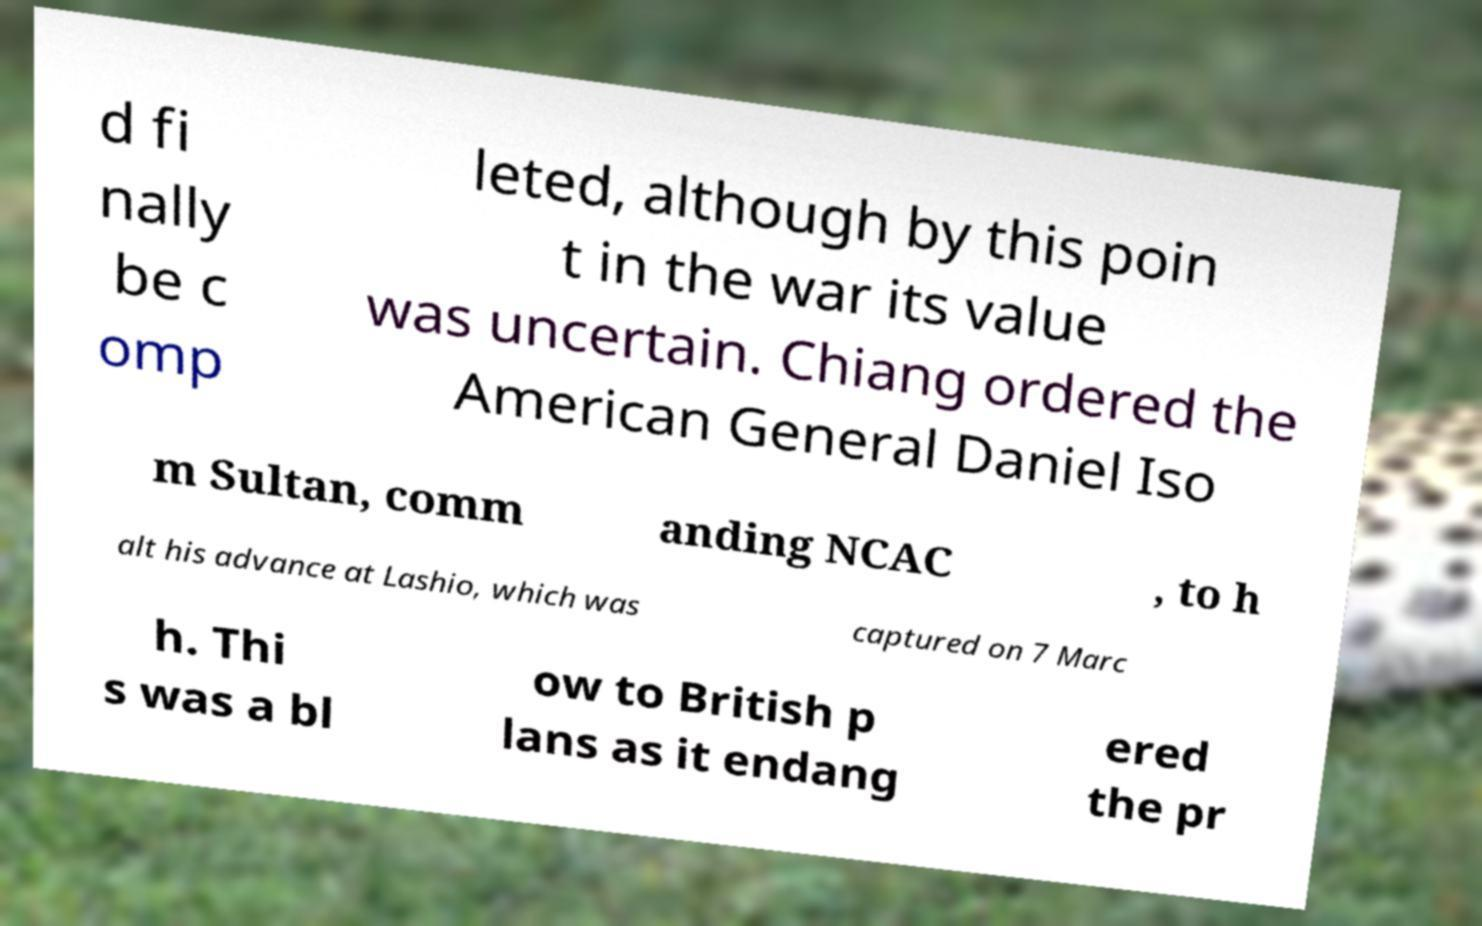Please read and relay the text visible in this image. What does it say? d fi nally be c omp leted, although by this poin t in the war its value was uncertain. Chiang ordered the American General Daniel Iso m Sultan, comm anding NCAC , to h alt his advance at Lashio, which was captured on 7 Marc h. Thi s was a bl ow to British p lans as it endang ered the pr 